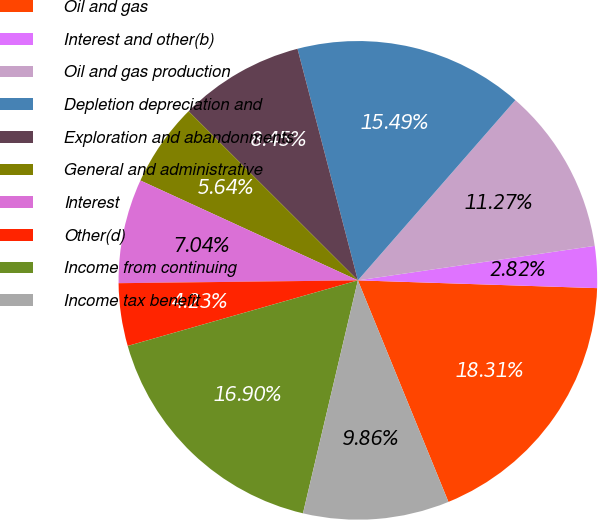Convert chart. <chart><loc_0><loc_0><loc_500><loc_500><pie_chart><fcel>Oil and gas<fcel>Interest and other(b)<fcel>Oil and gas production<fcel>Depletion depreciation and<fcel>Exploration and abandonments<fcel>General and administrative<fcel>Interest<fcel>Other(d)<fcel>Income from continuing<fcel>Income tax benefit<nl><fcel>18.31%<fcel>2.82%<fcel>11.27%<fcel>15.49%<fcel>8.45%<fcel>5.64%<fcel>7.04%<fcel>4.23%<fcel>16.9%<fcel>9.86%<nl></chart> 